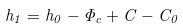Convert formula to latex. <formula><loc_0><loc_0><loc_500><loc_500>h _ { 1 } = h _ { 0 } - \Phi _ { c } + C - C _ { 0 }</formula> 